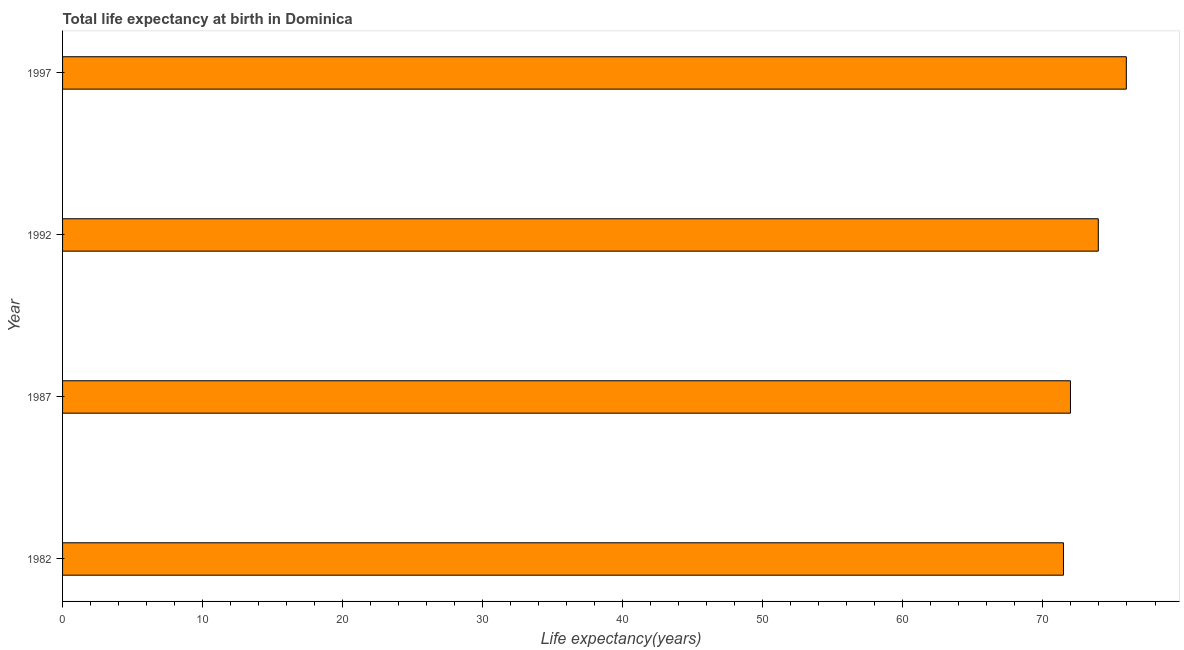Does the graph contain any zero values?
Give a very brief answer. No. What is the title of the graph?
Provide a succinct answer. Total life expectancy at birth in Dominica. What is the label or title of the X-axis?
Offer a terse response. Life expectancy(years). What is the label or title of the Y-axis?
Offer a terse response. Year. What is the life expectancy at birth in 1997?
Provide a short and direct response. 75.95. Across all years, what is the maximum life expectancy at birth?
Keep it short and to the point. 75.95. Across all years, what is the minimum life expectancy at birth?
Your answer should be very brief. 71.46. In which year was the life expectancy at birth maximum?
Your response must be concise. 1997. In which year was the life expectancy at birth minimum?
Keep it short and to the point. 1982. What is the sum of the life expectancy at birth?
Provide a short and direct response. 293.33. What is the difference between the life expectancy at birth in 1987 and 1992?
Offer a terse response. -1.99. What is the average life expectancy at birth per year?
Keep it short and to the point. 73.33. What is the median life expectancy at birth?
Provide a succinct answer. 72.96. Do a majority of the years between 1992 and 1997 (inclusive) have life expectancy at birth greater than 20 years?
Your answer should be very brief. Yes. Is the life expectancy at birth in 1982 less than that in 1992?
Offer a very short reply. Yes. What is the difference between the highest and the second highest life expectancy at birth?
Offer a terse response. 2. What is the difference between the highest and the lowest life expectancy at birth?
Make the answer very short. 4.49. How many years are there in the graph?
Offer a terse response. 4. Are the values on the major ticks of X-axis written in scientific E-notation?
Give a very brief answer. No. What is the Life expectancy(years) in 1982?
Your answer should be very brief. 71.46. What is the Life expectancy(years) of 1987?
Ensure brevity in your answer.  71.96. What is the Life expectancy(years) in 1992?
Your answer should be compact. 73.95. What is the Life expectancy(years) of 1997?
Provide a succinct answer. 75.95. What is the difference between the Life expectancy(years) in 1982 and 1992?
Keep it short and to the point. -2.49. What is the difference between the Life expectancy(years) in 1982 and 1997?
Make the answer very short. -4.49. What is the difference between the Life expectancy(years) in 1987 and 1992?
Make the answer very short. -1.99. What is the difference between the Life expectancy(years) in 1987 and 1997?
Offer a terse response. -3.99. What is the ratio of the Life expectancy(years) in 1982 to that in 1987?
Provide a succinct answer. 0.99. What is the ratio of the Life expectancy(years) in 1982 to that in 1997?
Keep it short and to the point. 0.94. What is the ratio of the Life expectancy(years) in 1987 to that in 1997?
Your answer should be very brief. 0.95. What is the ratio of the Life expectancy(years) in 1992 to that in 1997?
Ensure brevity in your answer.  0.97. 